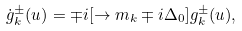Convert formula to latex. <formula><loc_0><loc_0><loc_500><loc_500>\dot { g } _ { k } ^ { \pm } ( u ) = \mp i [ \to m _ { k } \mp i \Delta _ { 0 } ] g _ { k } ^ { \pm } ( u ) ,</formula> 